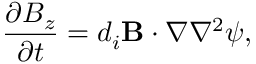Convert formula to latex. <formula><loc_0><loc_0><loc_500><loc_500>\frac { \partial B _ { z } } { \partial t } = d _ { i } { B } \cdot \boldsymbol \nabla \nabla ^ { 2 } \psi ,</formula> 